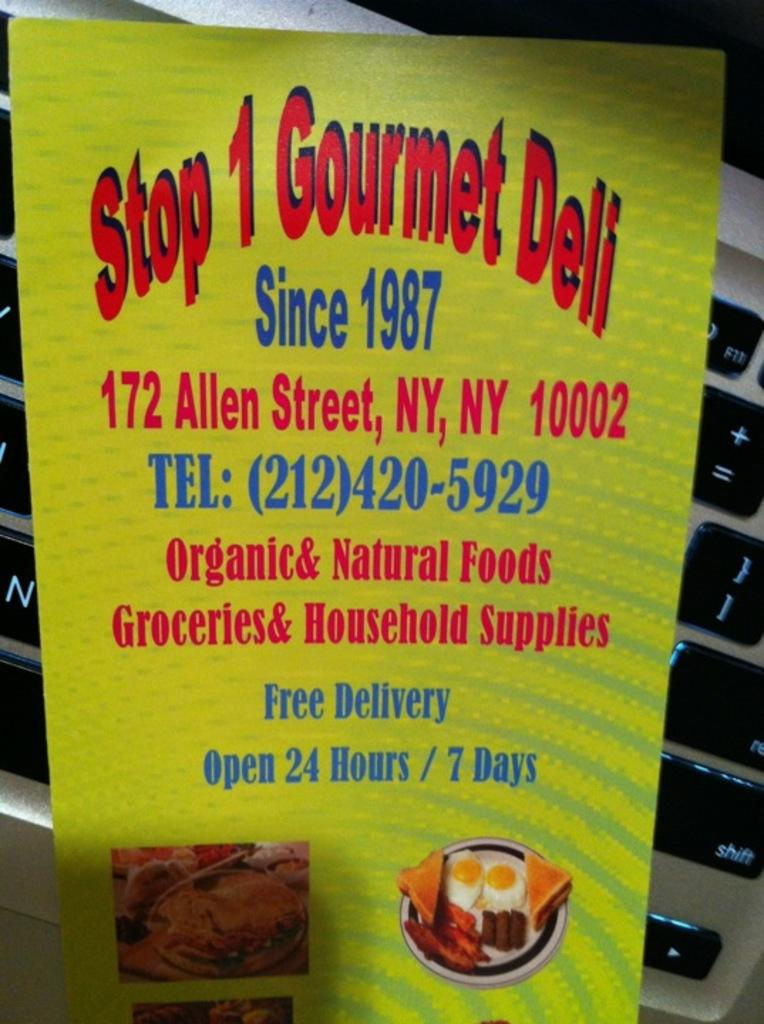What is the main object in the center of the image? There is a board in the center of the image. Can you describe any other objects visible in the image? In the background of the image, there is a laptop. What type of coal is being used to fuel the exchange on the board in the image? There is no coal or exchange present in the image; it only features a board and a laptop. 